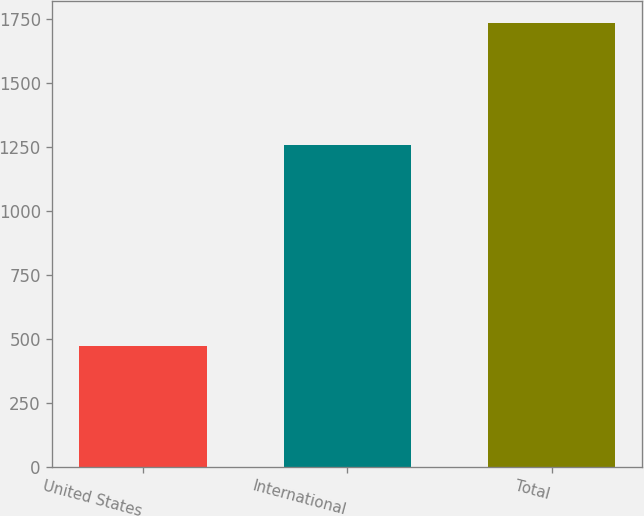Convert chart to OTSL. <chart><loc_0><loc_0><loc_500><loc_500><bar_chart><fcel>United States<fcel>International<fcel>Total<nl><fcel>475<fcel>1260<fcel>1735<nl></chart> 